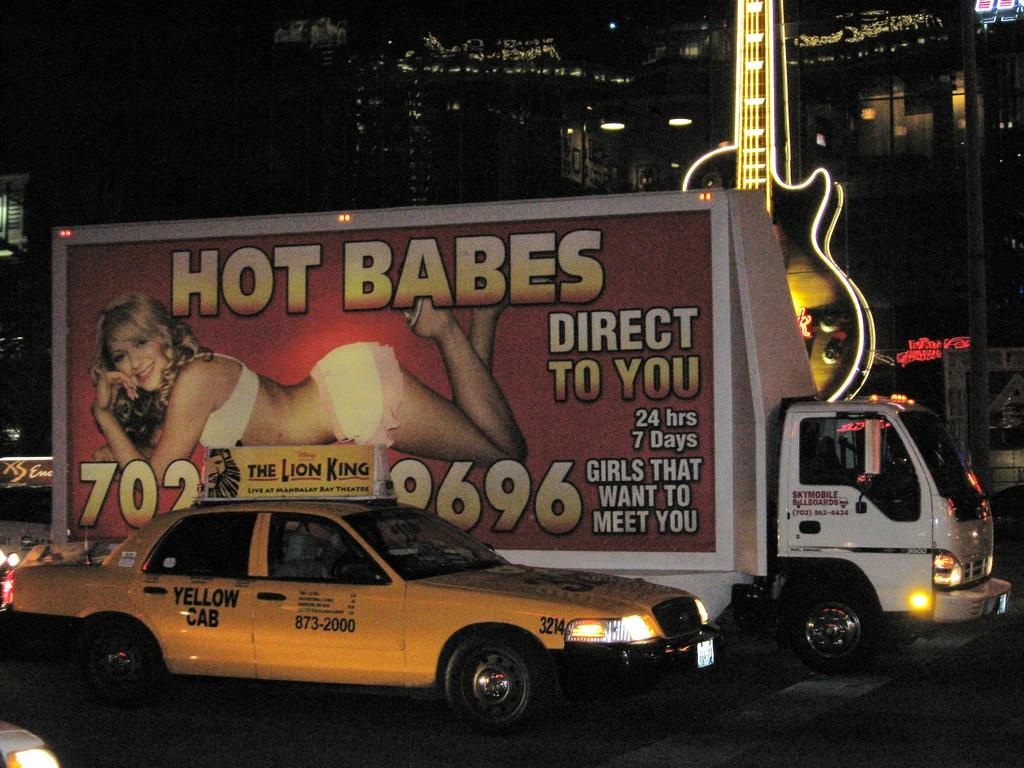Provide a one-sentence caption for the provided image. Sky Mobile Billboards advertising van is in traffic. 